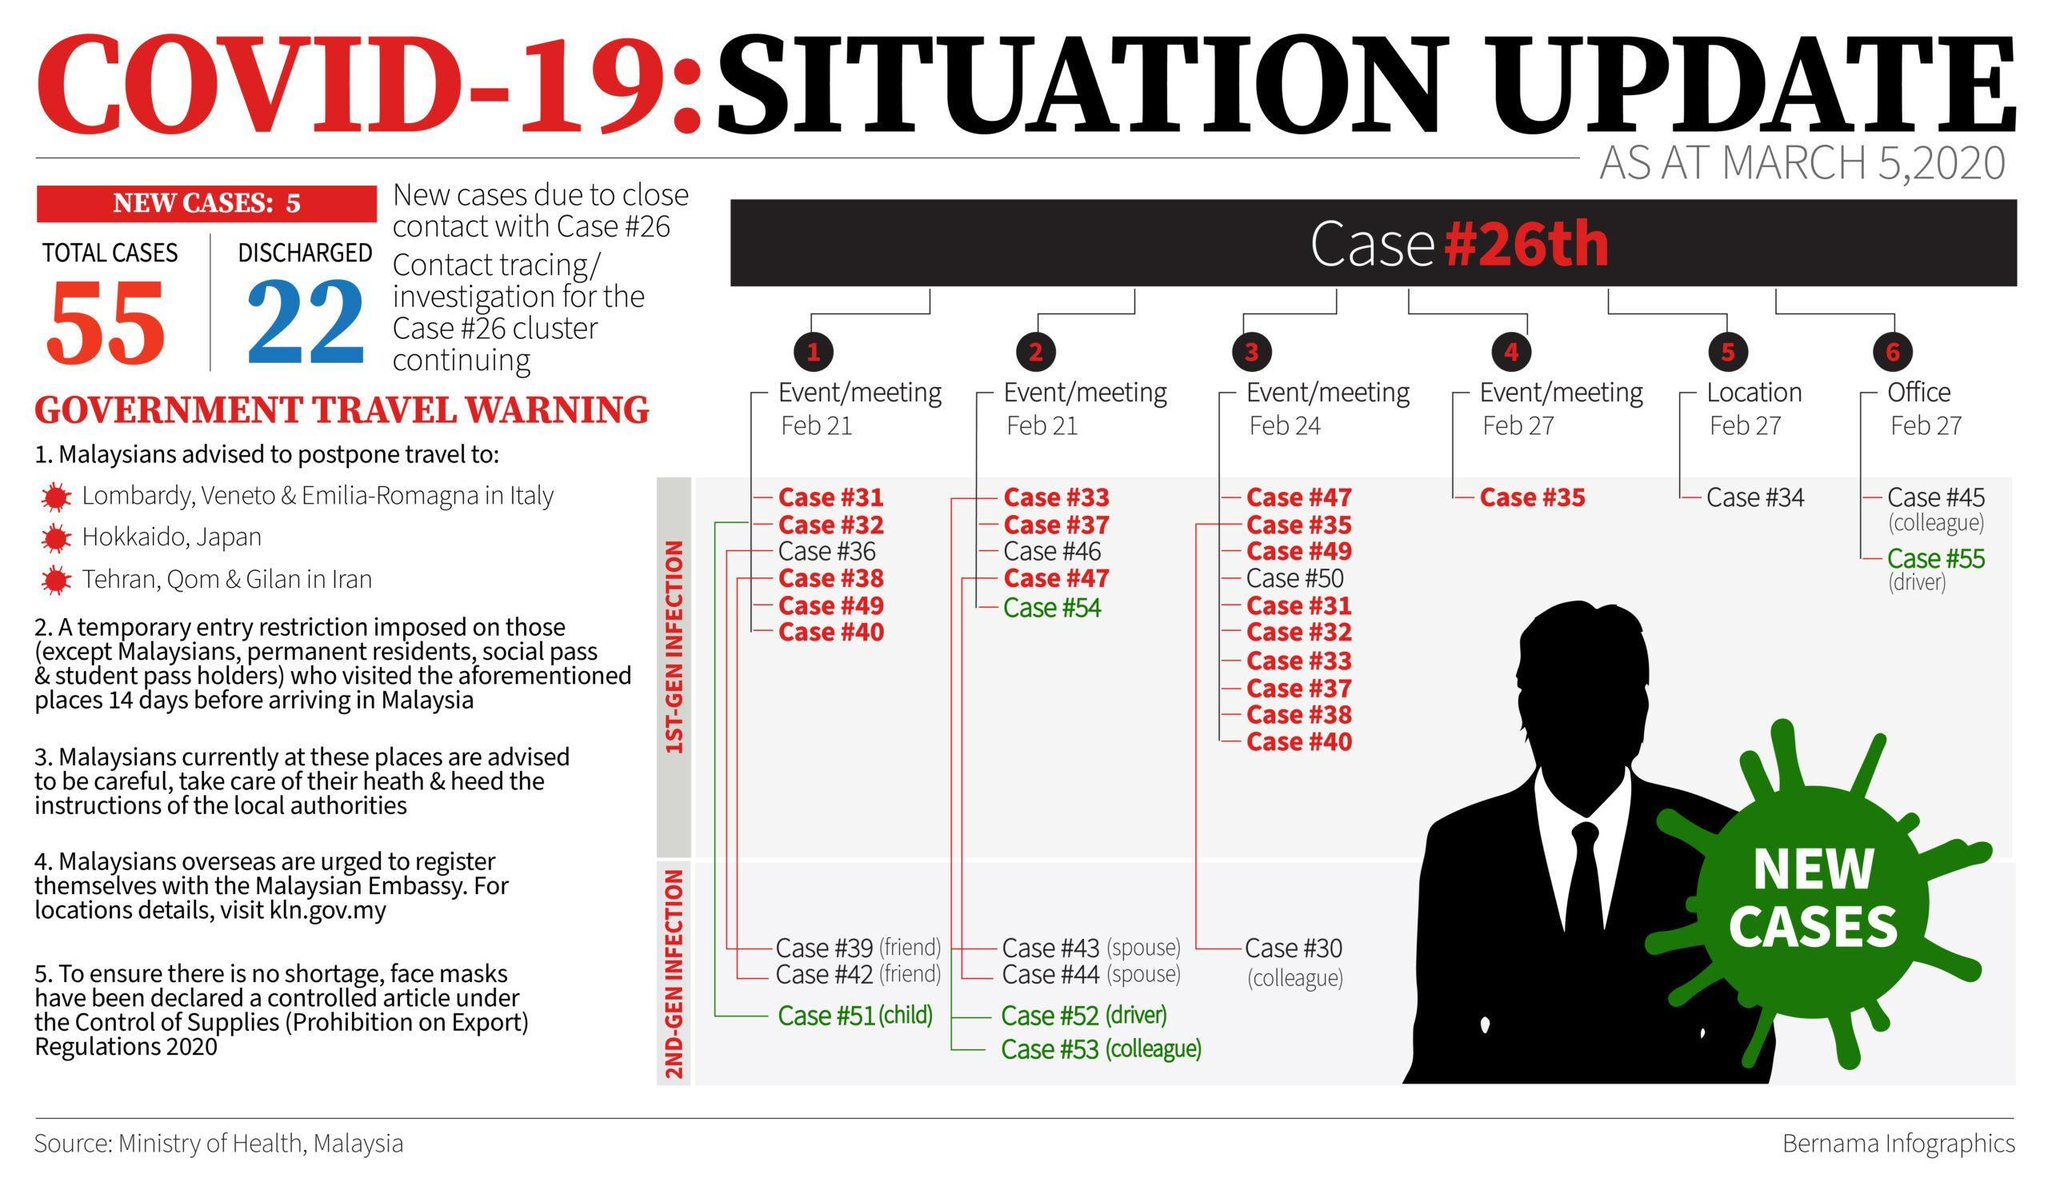Out of the total cases how many are still active cases?
Answer the question with a short phrase. 33 